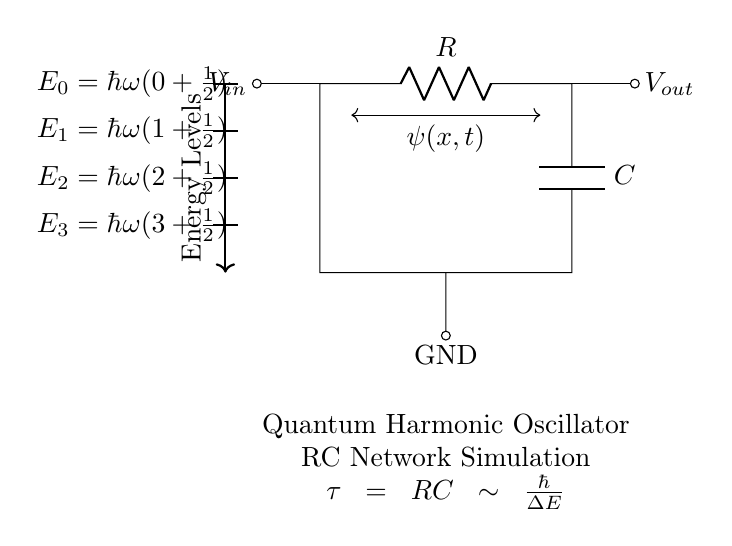What is the type of circuit depicted? The circuit represents a Resistor-Capacitor network, which is commonly used in various applications including filters and oscillators. The components are clearly labeled as a resistor and a capacitor.
Answer: Resistor-Capacitor What is the symbol for the capacitor in this diagram? The capacitor is represented by two parallel lines, with the label 'C' next to it indicating its capacitance. This is a standard representation in circuit diagrams.
Answer: Two parallel lines What does the letter 'R' represent? The letter 'R' is a standard symbol used to denote a resistor in circuit diagrams, and it indicates the resistance value of that component.
Answer: Resistor What does the time constant 'tau' signify in this circuit? The time constant tau represents the product of the resistance and capacitance (RC), determining the speed of the charging and discharging in the RC circuit, which is pivotal for simulating time-dependent systems like quantum harmonic oscillators.
Answer: RC What do the energy levels in the circuit diagram represent? The energy levels indicate the quantized energies of the quantum harmonic oscillator, represented by the formula E_n = h_bar omega (n + 1/2). Each level corresponds to specific states of the system that can be simulated by the RC circuit.
Answer: Quantized energies How does this circuit relate to quantum mechanics? This RC circuit simulates the behavior of a quantum harmonic oscillator, where the time constant (tau = RC) is related to the Planck constant divided by the energy difference, indicating a deep connection between classical circuits and quantum systems.
Answer: Quantum harmonic oscillator simulation 